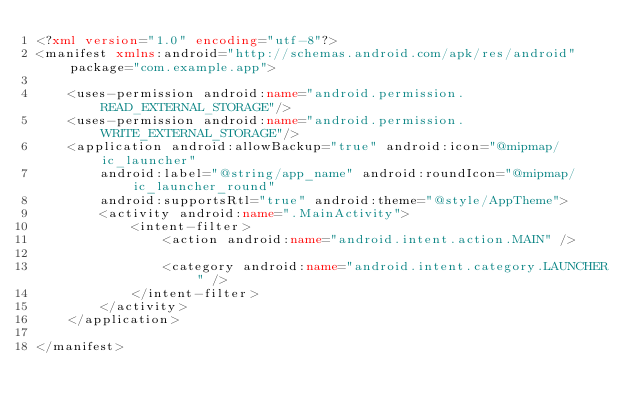Convert code to text. <code><loc_0><loc_0><loc_500><loc_500><_XML_><?xml version="1.0" encoding="utf-8"?>
<manifest xmlns:android="http://schemas.android.com/apk/res/android" package="com.example.app">

    <uses-permission android:name="android.permission.READ_EXTERNAL_STORAGE"/>
    <uses-permission android:name="android.permission.WRITE_EXTERNAL_STORAGE"/>
    <application android:allowBackup="true" android:icon="@mipmap/ic_launcher"
        android:label="@string/app_name" android:roundIcon="@mipmap/ic_launcher_round"
        android:supportsRtl="true" android:theme="@style/AppTheme">
        <activity android:name=".MainActivity">
            <intent-filter>
                <action android:name="android.intent.action.MAIN" />

                <category android:name="android.intent.category.LAUNCHER" />
            </intent-filter>
        </activity>
    </application>

</manifest></code> 